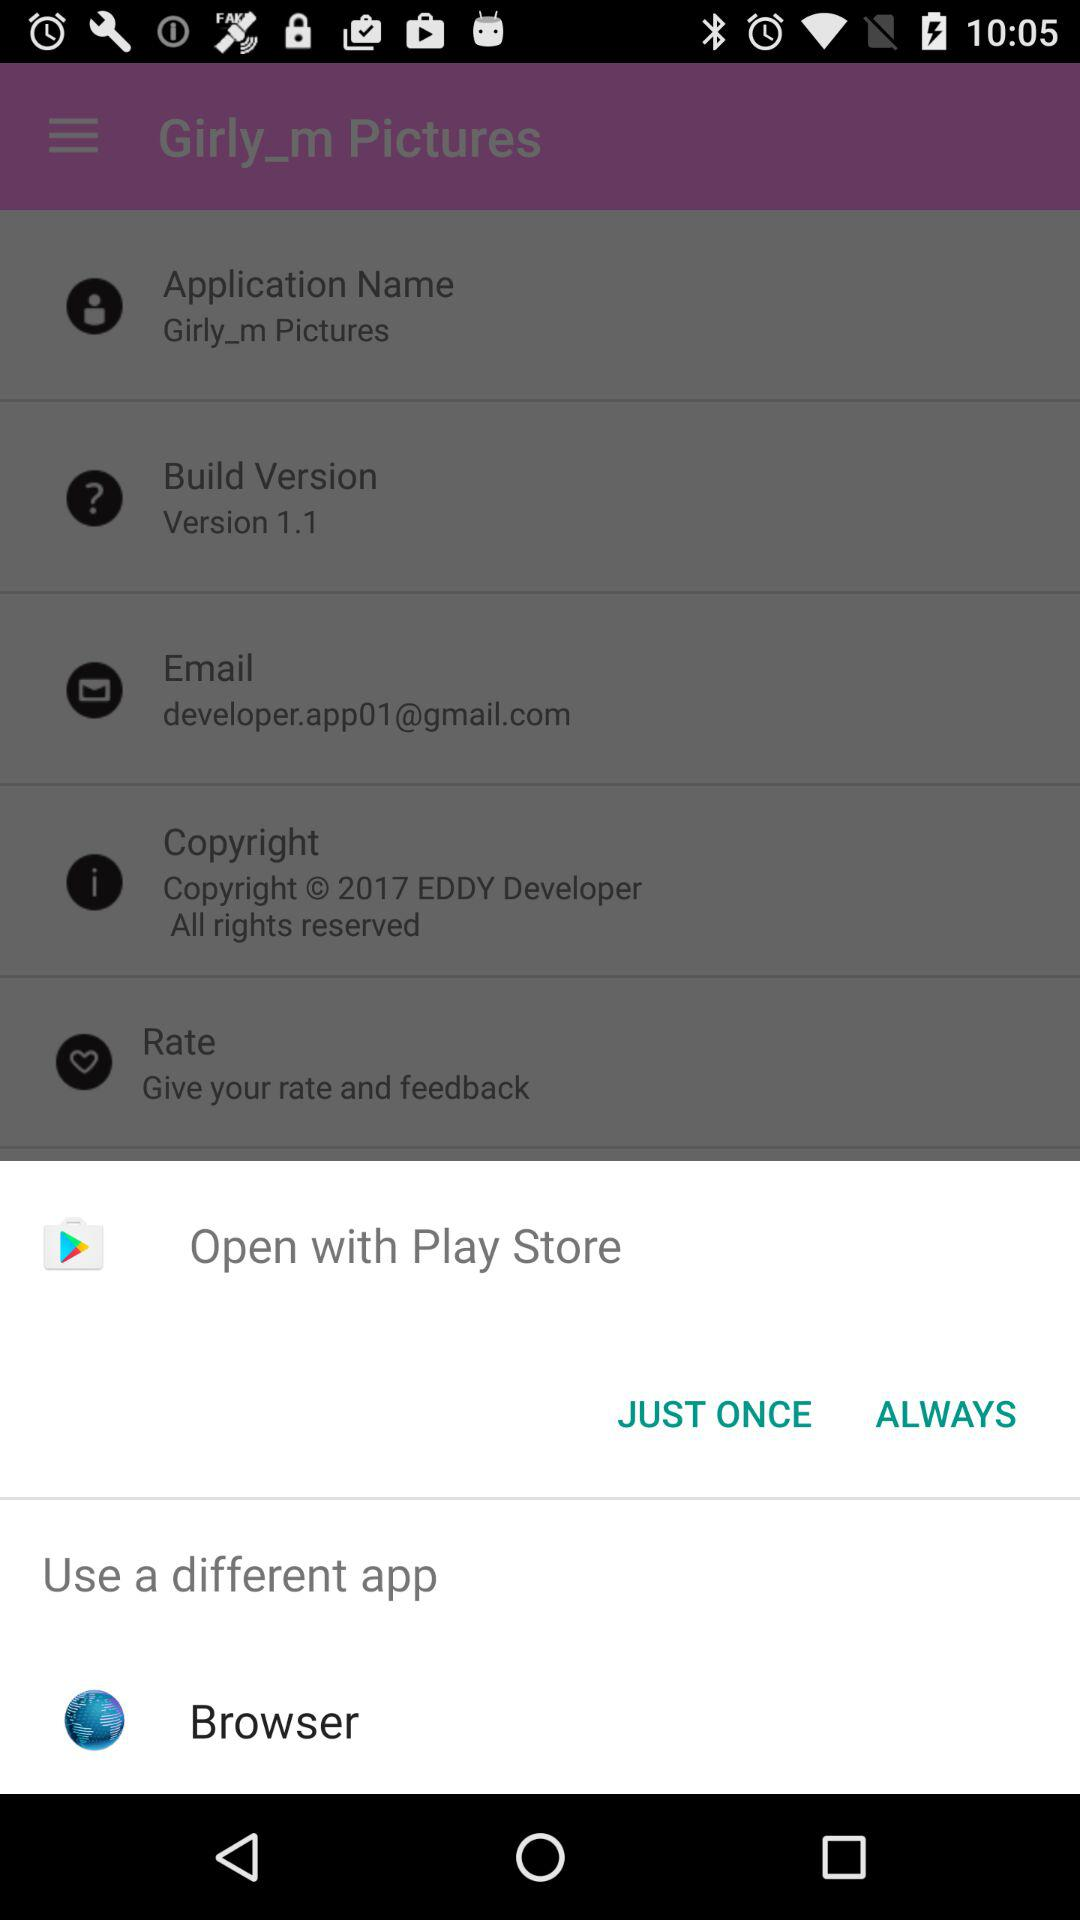Which applications can be used to open? The applications that can be used to open are "Play Store" and "Browser". 